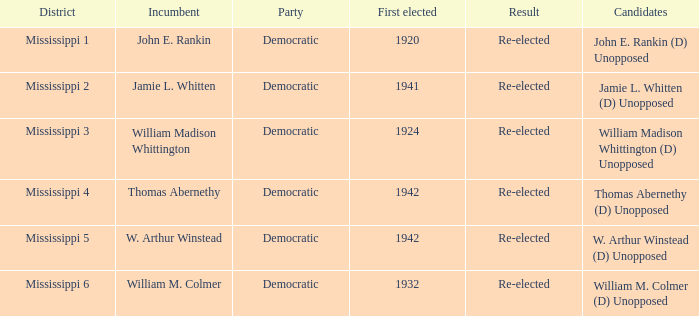What candidates are from mississippi 6? William M. Colmer (D) Unopposed. 